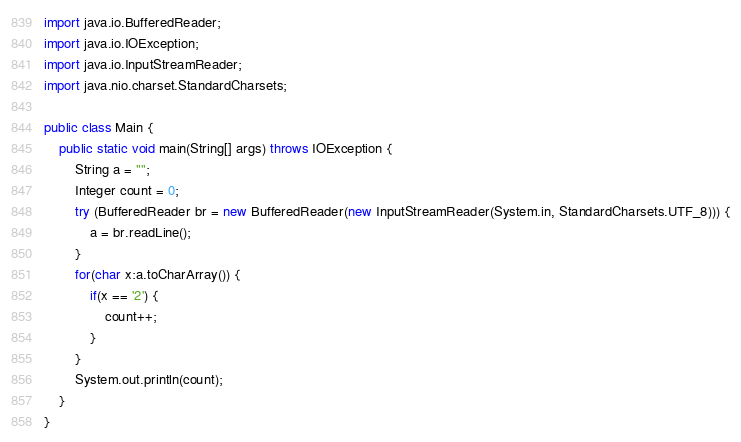Convert code to text. <code><loc_0><loc_0><loc_500><loc_500><_Java_>import java.io.BufferedReader;
import java.io.IOException;
import java.io.InputStreamReader;
import java.nio.charset.StandardCharsets;

public class Main {
	public static void main(String[] args) throws IOException {
		String a = "";
		Integer count = 0;
		try (BufferedReader br = new BufferedReader(new InputStreamReader(System.in, StandardCharsets.UTF_8))) {
			a = br.readLine();
		}
		for(char x:a.toCharArray()) {
			if(x == '2') {
				count++;
			}
		}
		System.out.println(count);
	}
}</code> 